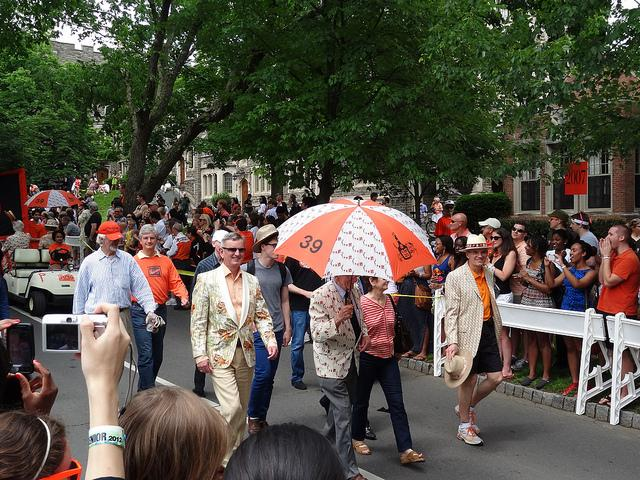What event is being filmed here? Please explain your reasoning. parade. This is a walk or march in public in a formal procession or in an ostentatious or attention-seeking way.  there is an abundant amount of attention from people on both sides. 